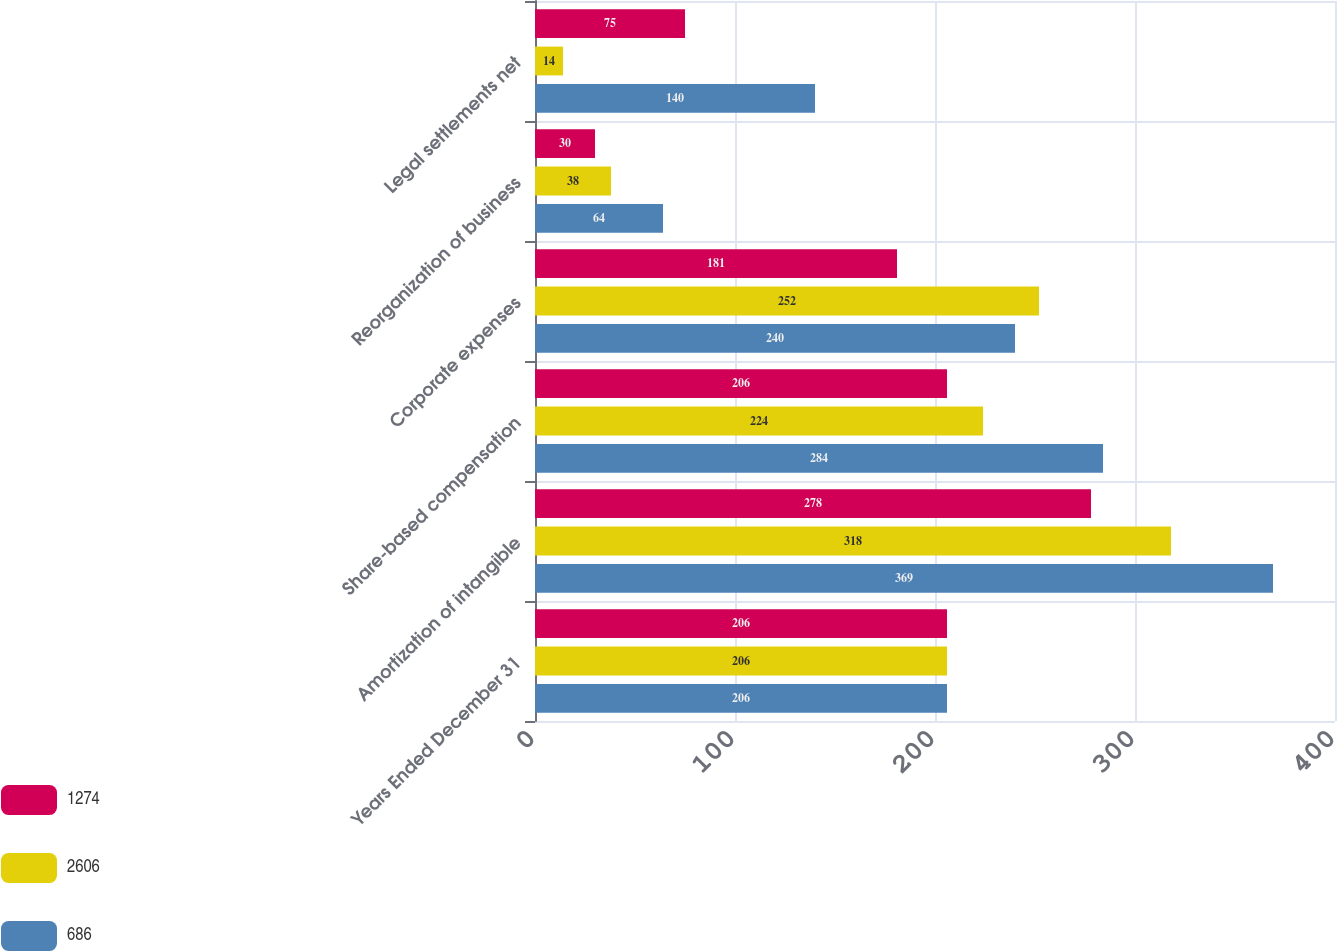Convert chart. <chart><loc_0><loc_0><loc_500><loc_500><stacked_bar_chart><ecel><fcel>Years Ended December 31<fcel>Amortization of intangible<fcel>Share-based compensation<fcel>Corporate expenses<fcel>Reorganization of business<fcel>Legal settlements net<nl><fcel>1274<fcel>206<fcel>278<fcel>206<fcel>181<fcel>30<fcel>75<nl><fcel>2606<fcel>206<fcel>318<fcel>224<fcel>252<fcel>38<fcel>14<nl><fcel>686<fcel>206<fcel>369<fcel>284<fcel>240<fcel>64<fcel>140<nl></chart> 